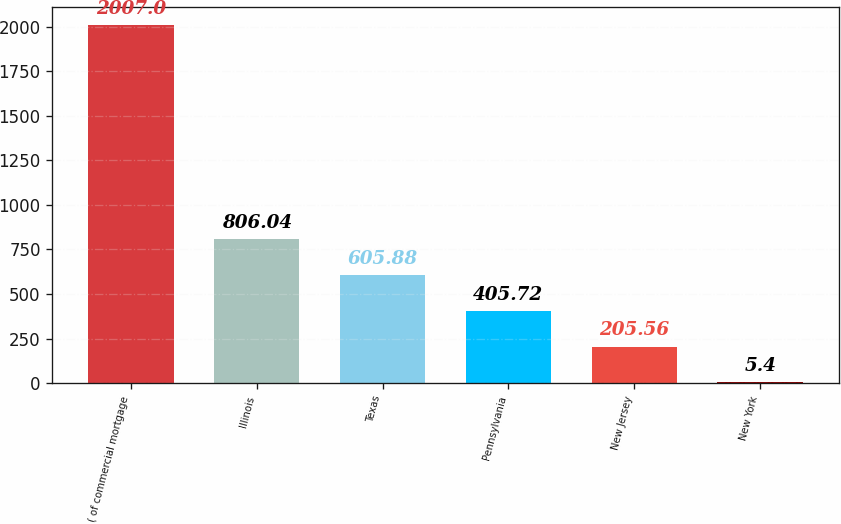Convert chart. <chart><loc_0><loc_0><loc_500><loc_500><bar_chart><fcel>( of commercial mortgage<fcel>Illinois<fcel>Texas<fcel>Pennsylvania<fcel>New Jersey<fcel>New York<nl><fcel>2007<fcel>806.04<fcel>605.88<fcel>405.72<fcel>205.56<fcel>5.4<nl></chart> 